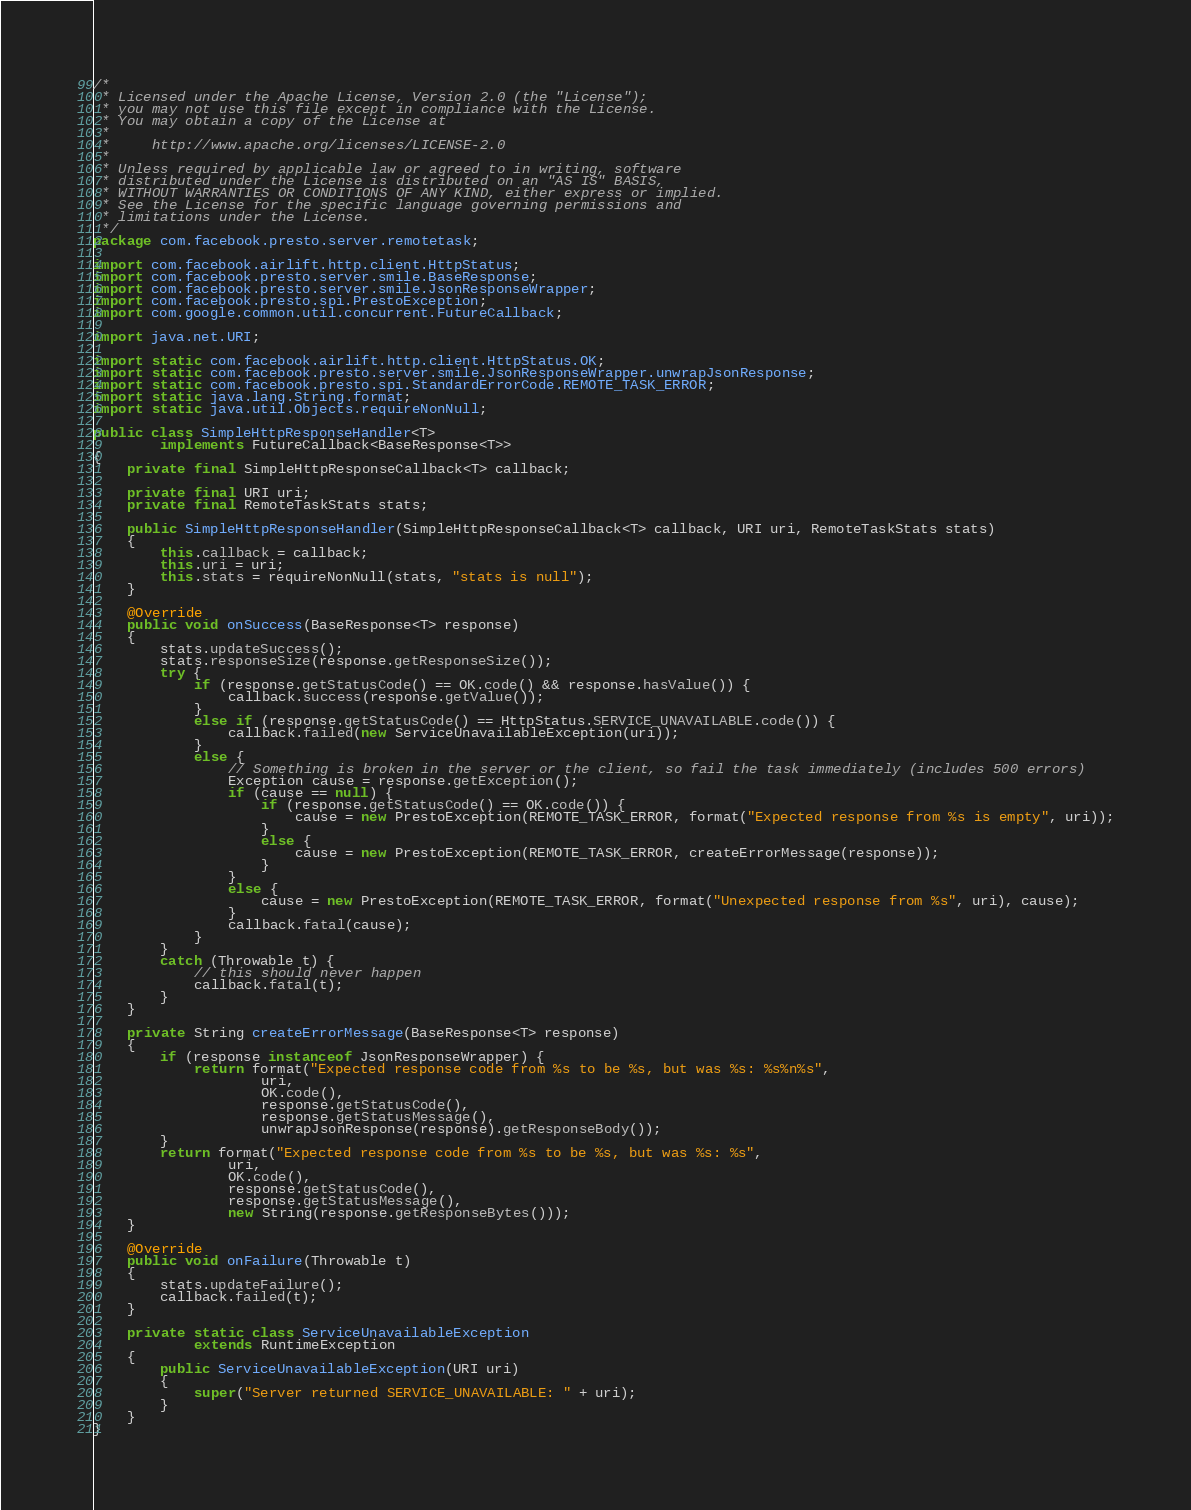Convert code to text. <code><loc_0><loc_0><loc_500><loc_500><_Java_>/*
 * Licensed under the Apache License, Version 2.0 (the "License");
 * you may not use this file except in compliance with the License.
 * You may obtain a copy of the License at
 *
 *     http://www.apache.org/licenses/LICENSE-2.0
 *
 * Unless required by applicable law or agreed to in writing, software
 * distributed under the License is distributed on an "AS IS" BASIS,
 * WITHOUT WARRANTIES OR CONDITIONS OF ANY KIND, either express or implied.
 * See the License for the specific language governing permissions and
 * limitations under the License.
 */
package com.facebook.presto.server.remotetask;

import com.facebook.airlift.http.client.HttpStatus;
import com.facebook.presto.server.smile.BaseResponse;
import com.facebook.presto.server.smile.JsonResponseWrapper;
import com.facebook.presto.spi.PrestoException;
import com.google.common.util.concurrent.FutureCallback;

import java.net.URI;

import static com.facebook.airlift.http.client.HttpStatus.OK;
import static com.facebook.presto.server.smile.JsonResponseWrapper.unwrapJsonResponse;
import static com.facebook.presto.spi.StandardErrorCode.REMOTE_TASK_ERROR;
import static java.lang.String.format;
import static java.util.Objects.requireNonNull;

public class SimpleHttpResponseHandler<T>
        implements FutureCallback<BaseResponse<T>>
{
    private final SimpleHttpResponseCallback<T> callback;

    private final URI uri;
    private final RemoteTaskStats stats;

    public SimpleHttpResponseHandler(SimpleHttpResponseCallback<T> callback, URI uri, RemoteTaskStats stats)
    {
        this.callback = callback;
        this.uri = uri;
        this.stats = requireNonNull(stats, "stats is null");
    }

    @Override
    public void onSuccess(BaseResponse<T> response)
    {
        stats.updateSuccess();
        stats.responseSize(response.getResponseSize());
        try {
            if (response.getStatusCode() == OK.code() && response.hasValue()) {
                callback.success(response.getValue());
            }
            else if (response.getStatusCode() == HttpStatus.SERVICE_UNAVAILABLE.code()) {
                callback.failed(new ServiceUnavailableException(uri));
            }
            else {
                // Something is broken in the server or the client, so fail the task immediately (includes 500 errors)
                Exception cause = response.getException();
                if (cause == null) {
                    if (response.getStatusCode() == OK.code()) {
                        cause = new PrestoException(REMOTE_TASK_ERROR, format("Expected response from %s is empty", uri));
                    }
                    else {
                        cause = new PrestoException(REMOTE_TASK_ERROR, createErrorMessage(response));
                    }
                }
                else {
                    cause = new PrestoException(REMOTE_TASK_ERROR, format("Unexpected response from %s", uri), cause);
                }
                callback.fatal(cause);
            }
        }
        catch (Throwable t) {
            // this should never happen
            callback.fatal(t);
        }
    }

    private String createErrorMessage(BaseResponse<T> response)
    {
        if (response instanceof JsonResponseWrapper) {
            return format("Expected response code from %s to be %s, but was %s: %s%n%s",
                    uri,
                    OK.code(),
                    response.getStatusCode(),
                    response.getStatusMessage(),
                    unwrapJsonResponse(response).getResponseBody());
        }
        return format("Expected response code from %s to be %s, but was %s: %s",
                uri,
                OK.code(),
                response.getStatusCode(),
                response.getStatusMessage(),
                new String(response.getResponseBytes()));
    }

    @Override
    public void onFailure(Throwable t)
    {
        stats.updateFailure();
        callback.failed(t);
    }

    private static class ServiceUnavailableException
            extends RuntimeException
    {
        public ServiceUnavailableException(URI uri)
        {
            super("Server returned SERVICE_UNAVAILABLE: " + uri);
        }
    }
}
</code> 